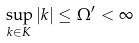Convert formula to latex. <formula><loc_0><loc_0><loc_500><loc_500>\sup _ { k \in K } | k | \leq \Omega ^ { \prime } < \infty</formula> 